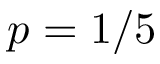<formula> <loc_0><loc_0><loc_500><loc_500>p = 1 / 5</formula> 